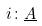<formula> <loc_0><loc_0><loc_500><loc_500>i \colon \underline { A }</formula> 